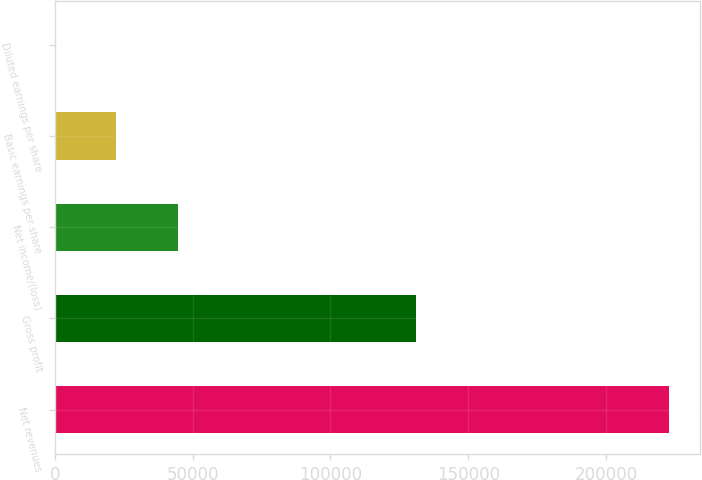<chart> <loc_0><loc_0><loc_500><loc_500><bar_chart><fcel>Net revenues<fcel>Gross profit<fcel>Net income/(loss)<fcel>Basic earnings per share<fcel>Diluted earnings per share<nl><fcel>222980<fcel>131024<fcel>44596.4<fcel>22298.4<fcel>0.44<nl></chart> 